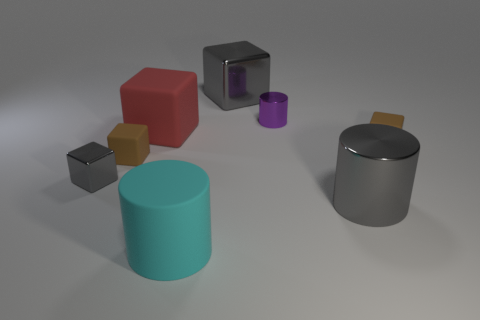Subtract all gray spheres. How many brown cubes are left? 2 Subtract all big metallic cylinders. How many cylinders are left? 2 Subtract 3 blocks. How many blocks are left? 2 Subtract all brown blocks. How many blocks are left? 3 Add 1 gray shiny cubes. How many objects exist? 9 Subtract all green cylinders. Subtract all cyan balls. How many cylinders are left? 3 Subtract all cubes. How many objects are left? 3 Subtract all metal objects. Subtract all large metal cubes. How many objects are left? 3 Add 4 large cyan matte cylinders. How many large cyan matte cylinders are left? 5 Add 7 small cyan rubber balls. How many small cyan rubber balls exist? 7 